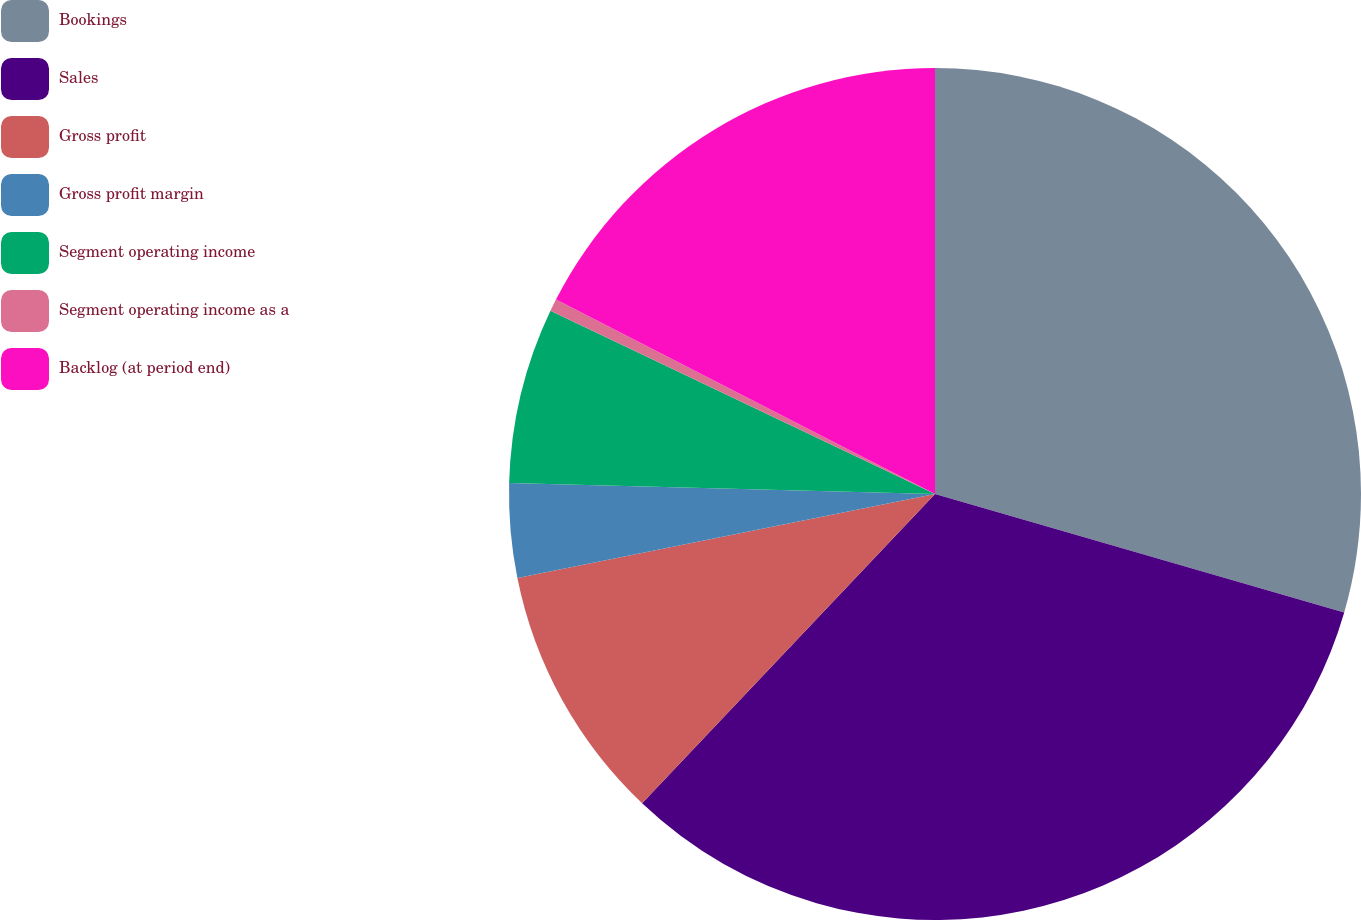<chart> <loc_0><loc_0><loc_500><loc_500><pie_chart><fcel>Bookings<fcel>Sales<fcel>Gross profit<fcel>Gross profit margin<fcel>Segment operating income<fcel>Segment operating income as a<fcel>Backlog (at period end)<nl><fcel>29.48%<fcel>32.58%<fcel>9.77%<fcel>3.57%<fcel>6.67%<fcel>0.47%<fcel>17.45%<nl></chart> 